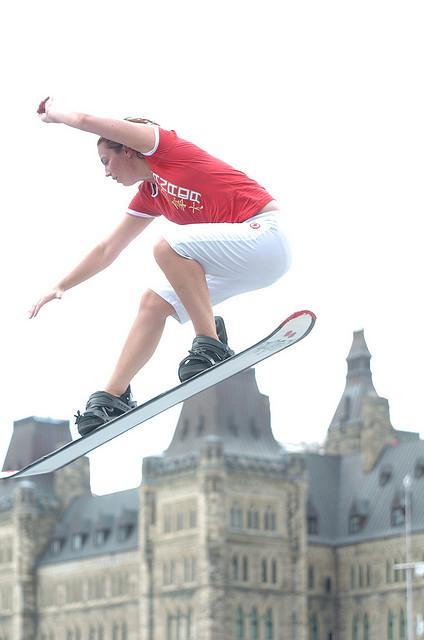Where is the woman?
Concise answer only. In air. How are the ladies hands?
Quick response, please. Up. What is the woman on?
Keep it brief. Snowboard. 